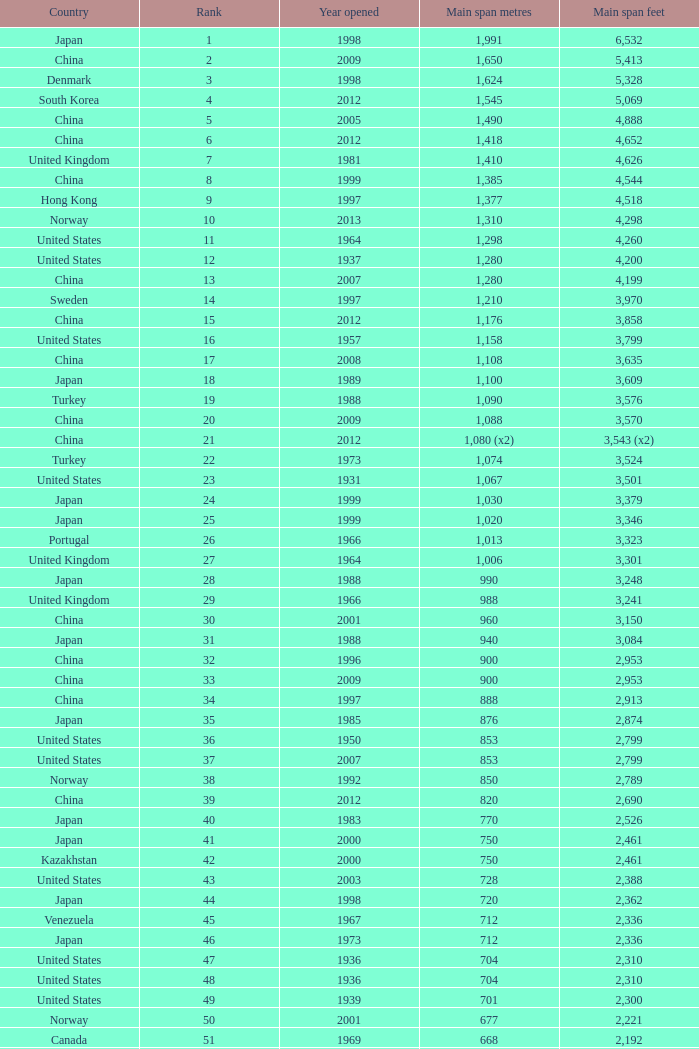What is the main span feet from opening year of 1936 in the United States with a rank greater than 47 and 421 main span metres? 1381.0. 